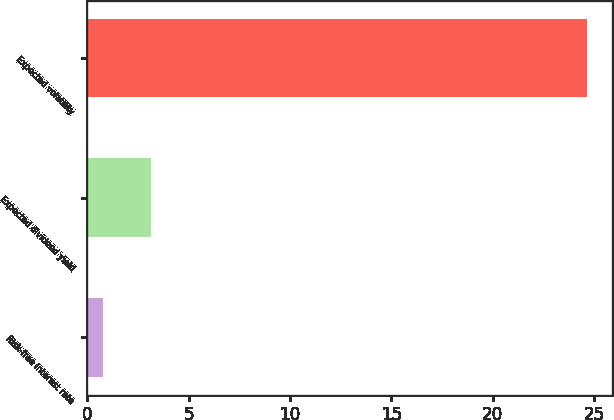Convert chart to OTSL. <chart><loc_0><loc_0><loc_500><loc_500><bar_chart><fcel>Risk-free interest rate<fcel>Expected dividend yield<fcel>Expected volatility<nl><fcel>0.75<fcel>3.14<fcel>24.65<nl></chart> 